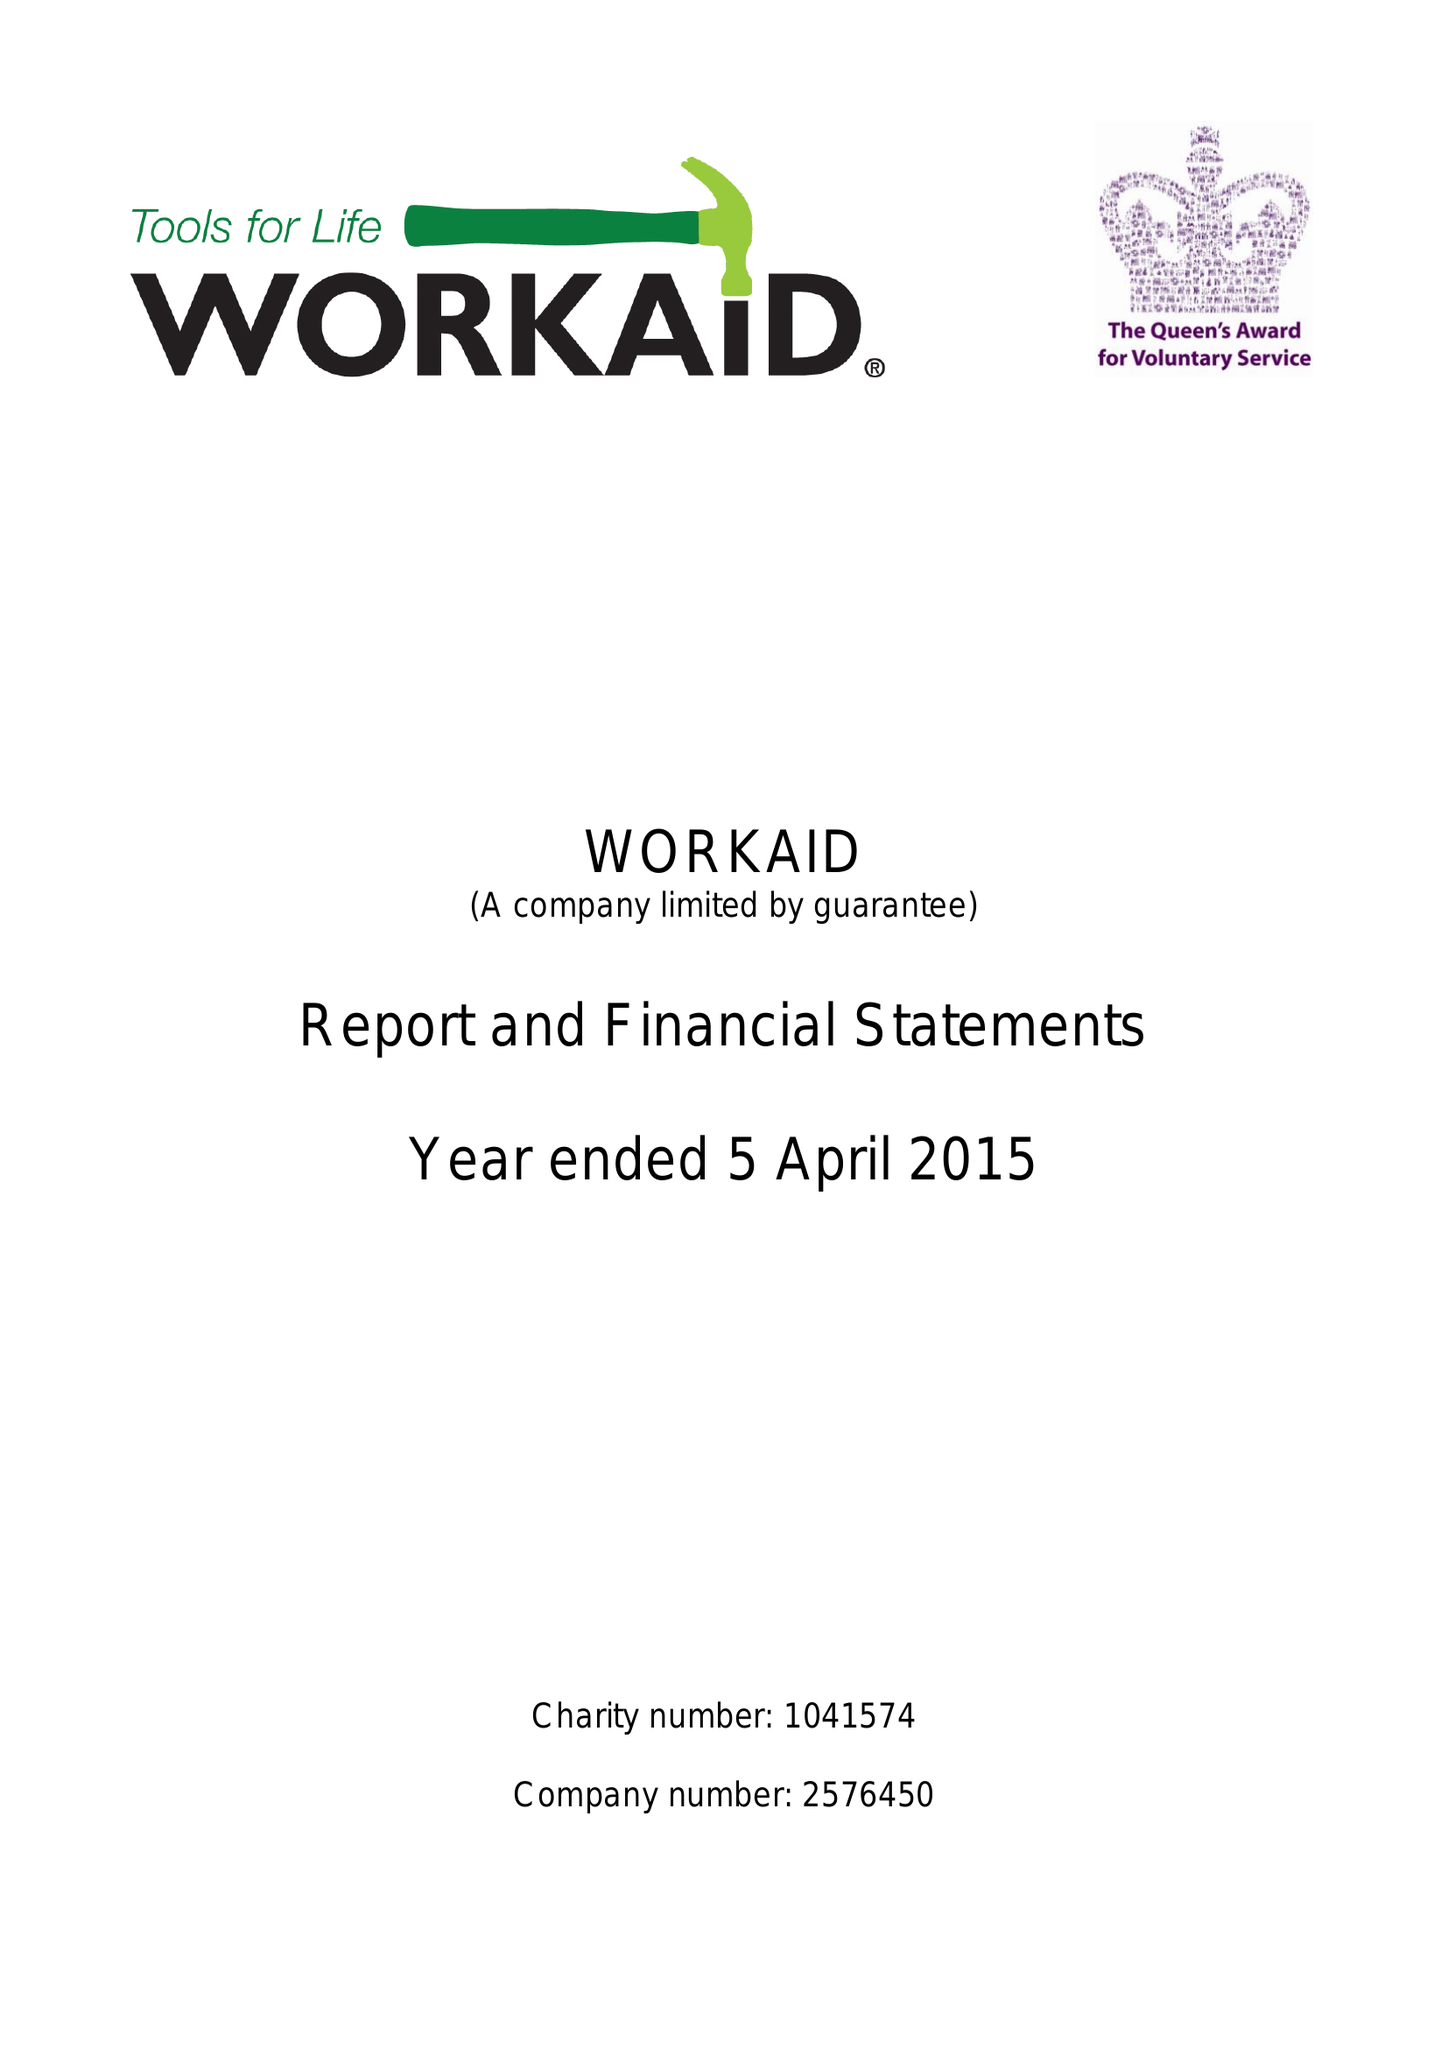What is the value for the address__street_line?
Answer the question using a single word or phrase. 71 TOWNSEND ROAD 